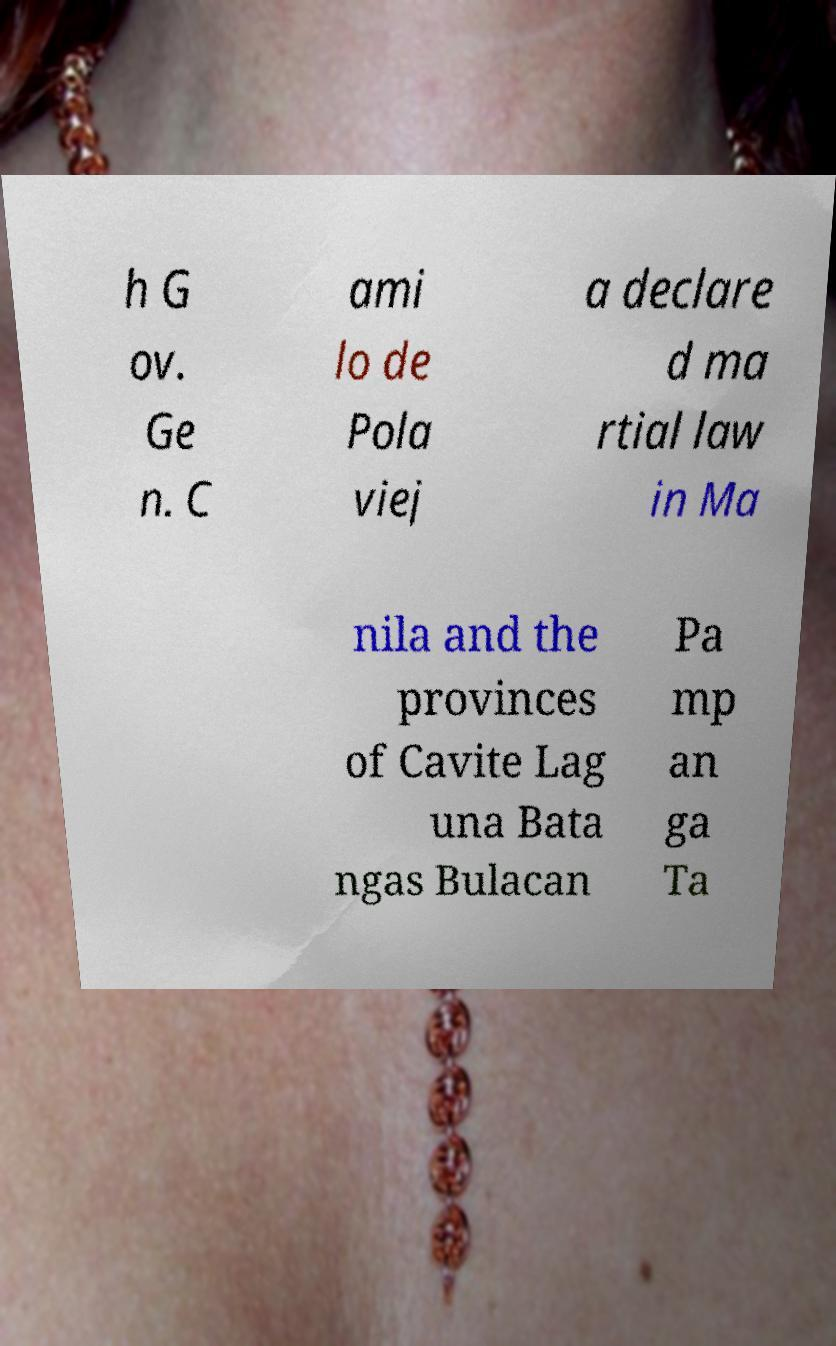I need the written content from this picture converted into text. Can you do that? h G ov. Ge n. C ami lo de Pola viej a declare d ma rtial law in Ma nila and the provinces of Cavite Lag una Bata ngas Bulacan Pa mp an ga Ta 